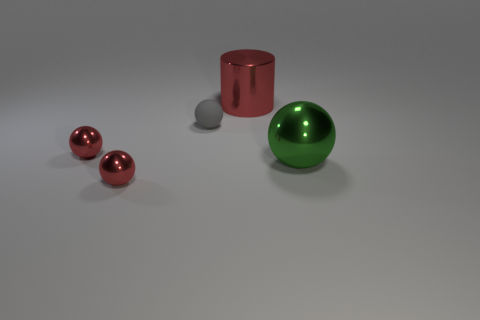Subtract all tiny rubber balls. How many balls are left? 3 Subtract 1 cylinders. How many cylinders are left? 0 Subtract all brown balls. How many brown cylinders are left? 0 Subtract all blue matte balls. Subtract all balls. How many objects are left? 1 Add 3 gray matte balls. How many gray matte balls are left? 4 Add 4 small metallic objects. How many small metallic objects exist? 6 Add 3 gray balls. How many objects exist? 8 Subtract all red spheres. How many spheres are left? 2 Subtract 1 gray balls. How many objects are left? 4 Subtract all cylinders. How many objects are left? 4 